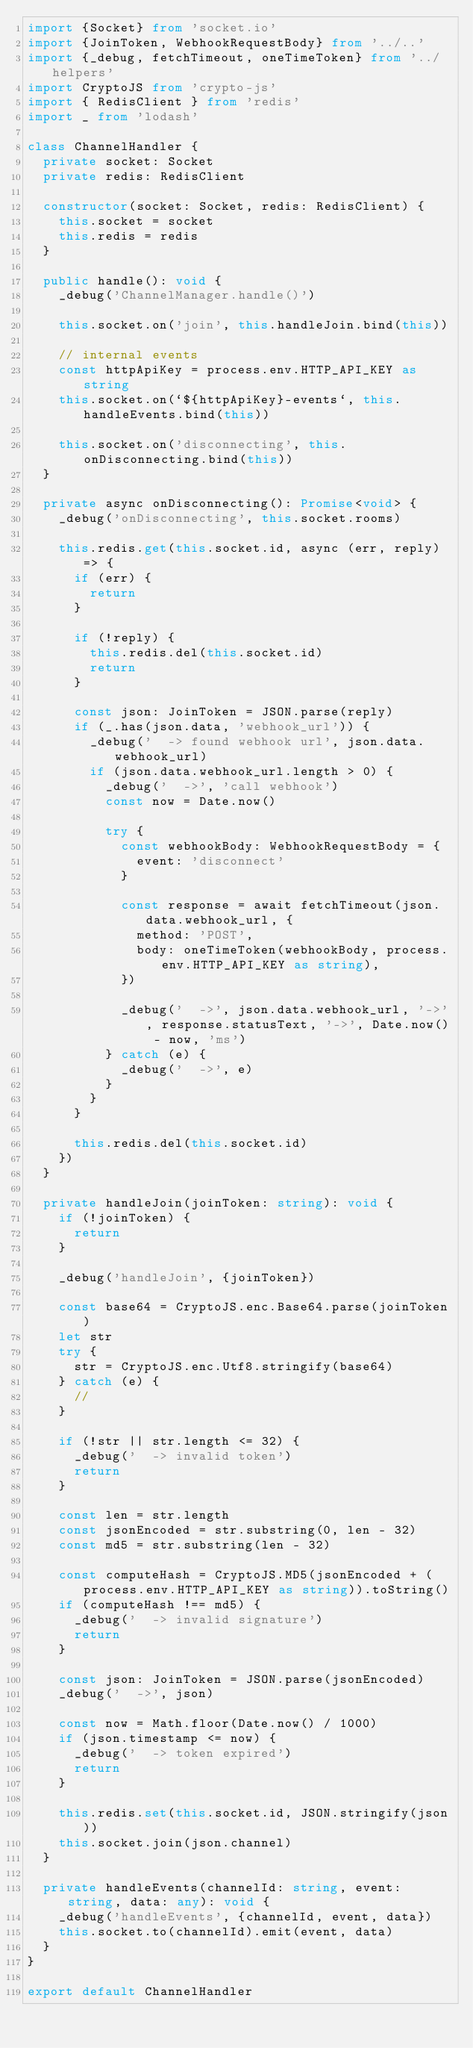<code> <loc_0><loc_0><loc_500><loc_500><_TypeScript_>import {Socket} from 'socket.io'
import {JoinToken, WebhookRequestBody} from '../..'
import {_debug, fetchTimeout, oneTimeToken} from '../helpers'
import CryptoJS from 'crypto-js'
import { RedisClient } from 'redis'
import _ from 'lodash'

class ChannelHandler {
  private socket: Socket
  private redis: RedisClient

  constructor(socket: Socket, redis: RedisClient) {
    this.socket = socket
    this.redis = redis
  }

  public handle(): void {
    _debug('ChannelManager.handle()')

    this.socket.on('join', this.handleJoin.bind(this))

    // internal events
    const httpApiKey = process.env.HTTP_API_KEY as string
    this.socket.on(`${httpApiKey}-events`, this.handleEvents.bind(this))

    this.socket.on('disconnecting', this.onDisconnecting.bind(this))
  }

  private async onDisconnecting(): Promise<void> {
    _debug('onDisconnecting', this.socket.rooms)

    this.redis.get(this.socket.id, async (err, reply) => {
      if (err) {
        return
      }

      if (!reply) {
        this.redis.del(this.socket.id)
        return
      }

      const json: JoinToken = JSON.parse(reply)
      if (_.has(json.data, 'webhook_url')) {
        _debug('  -> found webhook url', json.data.webhook_url)
        if (json.data.webhook_url.length > 0) {
          _debug('  ->', 'call webhook')
          const now = Date.now()

          try {
            const webhookBody: WebhookRequestBody = {
              event: 'disconnect'
            }

            const response = await fetchTimeout(json.data.webhook_url, {
              method: 'POST',
              body: oneTimeToken(webhookBody, process.env.HTTP_API_KEY as string),
            })

            _debug('  ->', json.data.webhook_url, '->', response.statusText, '->', Date.now() - now, 'ms')
          } catch (e) {
            _debug('  ->', e)
          }
        }
      }

      this.redis.del(this.socket.id)
    })
  }

  private handleJoin(joinToken: string): void {
    if (!joinToken) {
      return
    }

    _debug('handleJoin', {joinToken})

    const base64 = CryptoJS.enc.Base64.parse(joinToken)
    let str
    try {
      str = CryptoJS.enc.Utf8.stringify(base64)
    } catch (e) {
      //
    }

    if (!str || str.length <= 32) {
      _debug('  -> invalid token')
      return
    }

    const len = str.length
    const jsonEncoded = str.substring(0, len - 32)
    const md5 = str.substring(len - 32)

    const computeHash = CryptoJS.MD5(jsonEncoded + (process.env.HTTP_API_KEY as string)).toString()
    if (computeHash !== md5) {
      _debug('  -> invalid signature')
      return
    }

    const json: JoinToken = JSON.parse(jsonEncoded)
    _debug('  ->', json)

    const now = Math.floor(Date.now() / 1000)
    if (json.timestamp <= now) {
      _debug('  -> token expired')
      return
    }

    this.redis.set(this.socket.id, JSON.stringify(json))
    this.socket.join(json.channel)
  }

  private handleEvents(channelId: string, event: string, data: any): void {
    _debug('handleEvents', {channelId, event, data})
    this.socket.to(channelId).emit(event, data)
  }
}

export default ChannelHandler
</code> 